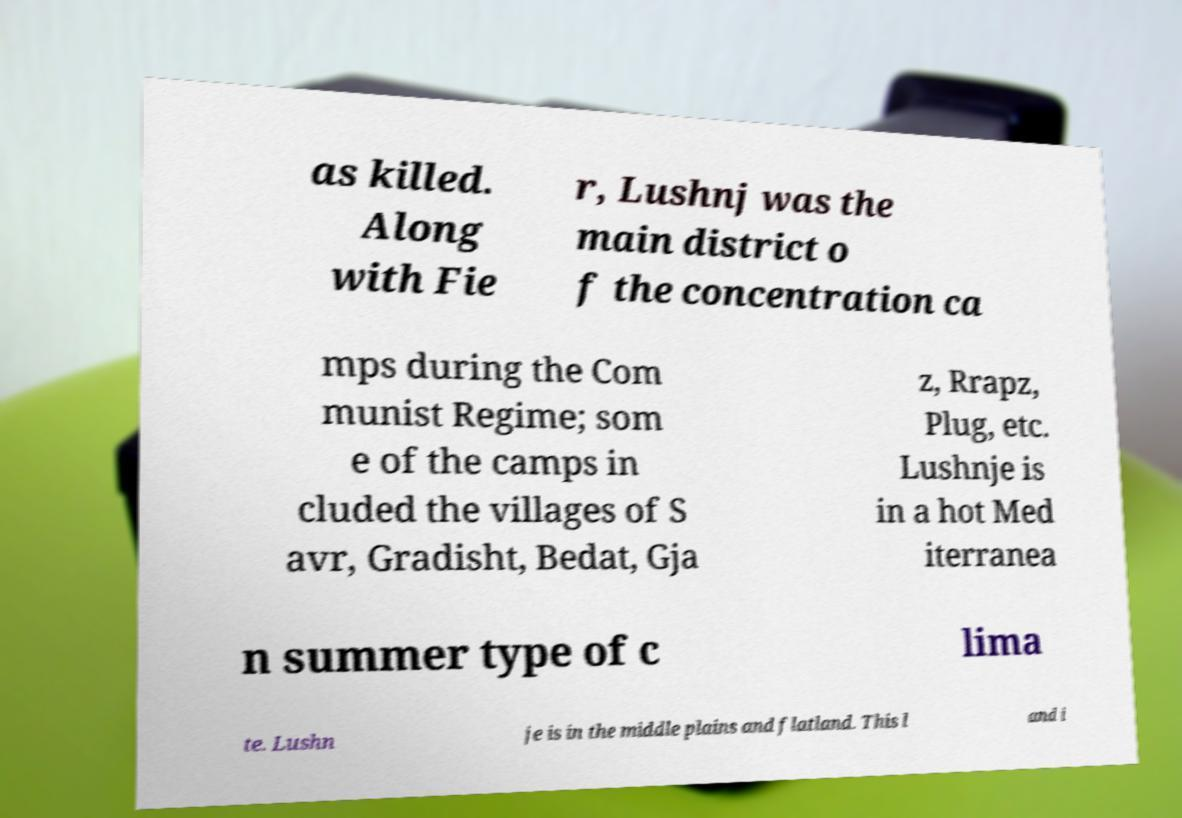Could you assist in decoding the text presented in this image and type it out clearly? as killed. Along with Fie r, Lushnj was the main district o f the concentration ca mps during the Com munist Regime; som e of the camps in cluded the villages of S avr, Gradisht, Bedat, Gja z, Rrapz, Plug, etc. Lushnje is in a hot Med iterranea n summer type of c lima te. Lushn je is in the middle plains and flatland. This l and i 